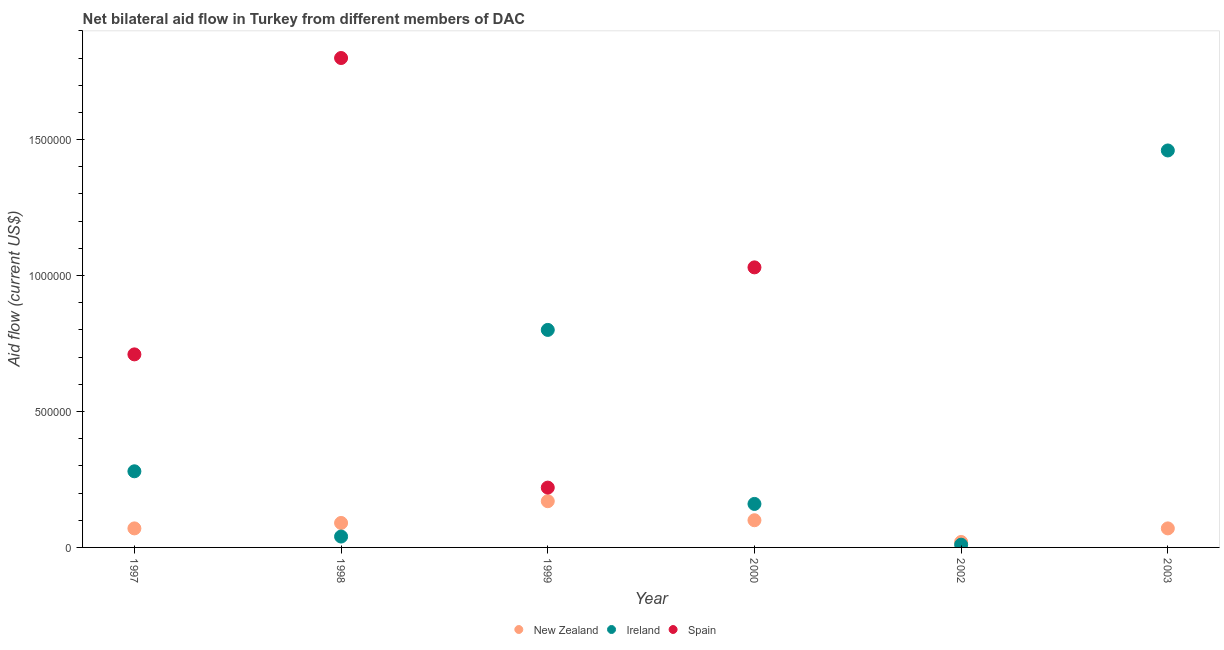How many different coloured dotlines are there?
Offer a terse response. 3. Across all years, what is the maximum amount of aid provided by ireland?
Your answer should be very brief. 1.46e+06. Across all years, what is the minimum amount of aid provided by ireland?
Give a very brief answer. 10000. In which year was the amount of aid provided by new zealand maximum?
Provide a succinct answer. 1999. What is the total amount of aid provided by spain in the graph?
Your answer should be very brief. 3.76e+06. What is the difference between the amount of aid provided by spain in 1997 and that in 1998?
Your answer should be very brief. -1.09e+06. What is the difference between the amount of aid provided by spain in 1998 and the amount of aid provided by new zealand in 2000?
Your response must be concise. 1.70e+06. What is the average amount of aid provided by new zealand per year?
Offer a very short reply. 8.67e+04. In the year 1999, what is the difference between the amount of aid provided by ireland and amount of aid provided by spain?
Keep it short and to the point. 5.80e+05. What is the ratio of the amount of aid provided by spain in 1998 to that in 2000?
Provide a succinct answer. 1.75. Is the amount of aid provided by ireland in 1999 less than that in 2003?
Your answer should be compact. Yes. Is the difference between the amount of aid provided by new zealand in 1998 and 1999 greater than the difference between the amount of aid provided by ireland in 1998 and 1999?
Provide a short and direct response. Yes. What is the difference between the highest and the second highest amount of aid provided by new zealand?
Your answer should be compact. 7.00e+04. What is the difference between the highest and the lowest amount of aid provided by spain?
Keep it short and to the point. 1.80e+06. In how many years, is the amount of aid provided by ireland greater than the average amount of aid provided by ireland taken over all years?
Your answer should be very brief. 2. Is the sum of the amount of aid provided by ireland in 2000 and 2003 greater than the maximum amount of aid provided by new zealand across all years?
Your answer should be compact. Yes. Does the amount of aid provided by spain monotonically increase over the years?
Offer a terse response. No. Is the amount of aid provided by spain strictly greater than the amount of aid provided by new zealand over the years?
Offer a terse response. No. How many dotlines are there?
Make the answer very short. 3. How many years are there in the graph?
Offer a terse response. 6. What is the difference between two consecutive major ticks on the Y-axis?
Provide a succinct answer. 5.00e+05. Are the values on the major ticks of Y-axis written in scientific E-notation?
Ensure brevity in your answer.  No. Does the graph contain grids?
Provide a short and direct response. No. How many legend labels are there?
Provide a succinct answer. 3. What is the title of the graph?
Offer a very short reply. Net bilateral aid flow in Turkey from different members of DAC. What is the label or title of the Y-axis?
Provide a succinct answer. Aid flow (current US$). What is the Aid flow (current US$) of Ireland in 1997?
Your answer should be compact. 2.80e+05. What is the Aid flow (current US$) of Spain in 1997?
Ensure brevity in your answer.  7.10e+05. What is the Aid flow (current US$) of Spain in 1998?
Provide a succinct answer. 1.80e+06. What is the Aid flow (current US$) of Spain in 1999?
Keep it short and to the point. 2.20e+05. What is the Aid flow (current US$) in Ireland in 2000?
Make the answer very short. 1.60e+05. What is the Aid flow (current US$) in Spain in 2000?
Provide a short and direct response. 1.03e+06. What is the Aid flow (current US$) in New Zealand in 2002?
Provide a short and direct response. 2.00e+04. What is the Aid flow (current US$) of Spain in 2002?
Give a very brief answer. 0. What is the Aid flow (current US$) of New Zealand in 2003?
Offer a very short reply. 7.00e+04. What is the Aid flow (current US$) of Ireland in 2003?
Ensure brevity in your answer.  1.46e+06. Across all years, what is the maximum Aid flow (current US$) in New Zealand?
Keep it short and to the point. 1.70e+05. Across all years, what is the maximum Aid flow (current US$) of Ireland?
Your response must be concise. 1.46e+06. Across all years, what is the maximum Aid flow (current US$) in Spain?
Give a very brief answer. 1.80e+06. Across all years, what is the minimum Aid flow (current US$) in New Zealand?
Keep it short and to the point. 2.00e+04. Across all years, what is the minimum Aid flow (current US$) in Ireland?
Keep it short and to the point. 10000. Across all years, what is the minimum Aid flow (current US$) of Spain?
Ensure brevity in your answer.  0. What is the total Aid flow (current US$) of New Zealand in the graph?
Provide a short and direct response. 5.20e+05. What is the total Aid flow (current US$) in Ireland in the graph?
Your answer should be compact. 2.75e+06. What is the total Aid flow (current US$) of Spain in the graph?
Give a very brief answer. 3.76e+06. What is the difference between the Aid flow (current US$) of Ireland in 1997 and that in 1998?
Your answer should be compact. 2.40e+05. What is the difference between the Aid flow (current US$) in Spain in 1997 and that in 1998?
Your answer should be compact. -1.09e+06. What is the difference between the Aid flow (current US$) in Ireland in 1997 and that in 1999?
Provide a short and direct response. -5.20e+05. What is the difference between the Aid flow (current US$) in Spain in 1997 and that in 1999?
Your response must be concise. 4.90e+05. What is the difference between the Aid flow (current US$) in New Zealand in 1997 and that in 2000?
Offer a terse response. -3.00e+04. What is the difference between the Aid flow (current US$) of Ireland in 1997 and that in 2000?
Give a very brief answer. 1.20e+05. What is the difference between the Aid flow (current US$) in Spain in 1997 and that in 2000?
Offer a very short reply. -3.20e+05. What is the difference between the Aid flow (current US$) in New Zealand in 1997 and that in 2003?
Your answer should be compact. 0. What is the difference between the Aid flow (current US$) of Ireland in 1997 and that in 2003?
Give a very brief answer. -1.18e+06. What is the difference between the Aid flow (current US$) of Ireland in 1998 and that in 1999?
Make the answer very short. -7.60e+05. What is the difference between the Aid flow (current US$) of Spain in 1998 and that in 1999?
Your answer should be compact. 1.58e+06. What is the difference between the Aid flow (current US$) in New Zealand in 1998 and that in 2000?
Give a very brief answer. -10000. What is the difference between the Aid flow (current US$) of Spain in 1998 and that in 2000?
Your response must be concise. 7.70e+05. What is the difference between the Aid flow (current US$) of New Zealand in 1998 and that in 2002?
Offer a very short reply. 7.00e+04. What is the difference between the Aid flow (current US$) in Ireland in 1998 and that in 2002?
Offer a very short reply. 3.00e+04. What is the difference between the Aid flow (current US$) of New Zealand in 1998 and that in 2003?
Offer a terse response. 2.00e+04. What is the difference between the Aid flow (current US$) in Ireland in 1998 and that in 2003?
Give a very brief answer. -1.42e+06. What is the difference between the Aid flow (current US$) in Ireland in 1999 and that in 2000?
Give a very brief answer. 6.40e+05. What is the difference between the Aid flow (current US$) of Spain in 1999 and that in 2000?
Offer a terse response. -8.10e+05. What is the difference between the Aid flow (current US$) of New Zealand in 1999 and that in 2002?
Offer a very short reply. 1.50e+05. What is the difference between the Aid flow (current US$) of Ireland in 1999 and that in 2002?
Ensure brevity in your answer.  7.90e+05. What is the difference between the Aid flow (current US$) of New Zealand in 1999 and that in 2003?
Offer a terse response. 1.00e+05. What is the difference between the Aid flow (current US$) in Ireland in 1999 and that in 2003?
Ensure brevity in your answer.  -6.60e+05. What is the difference between the Aid flow (current US$) of New Zealand in 2000 and that in 2002?
Ensure brevity in your answer.  8.00e+04. What is the difference between the Aid flow (current US$) in Ireland in 2000 and that in 2003?
Offer a very short reply. -1.30e+06. What is the difference between the Aid flow (current US$) of New Zealand in 2002 and that in 2003?
Ensure brevity in your answer.  -5.00e+04. What is the difference between the Aid flow (current US$) of Ireland in 2002 and that in 2003?
Offer a very short reply. -1.45e+06. What is the difference between the Aid flow (current US$) in New Zealand in 1997 and the Aid flow (current US$) in Ireland in 1998?
Offer a very short reply. 3.00e+04. What is the difference between the Aid flow (current US$) in New Zealand in 1997 and the Aid flow (current US$) in Spain in 1998?
Provide a succinct answer. -1.73e+06. What is the difference between the Aid flow (current US$) of Ireland in 1997 and the Aid flow (current US$) of Spain in 1998?
Offer a very short reply. -1.52e+06. What is the difference between the Aid flow (current US$) in New Zealand in 1997 and the Aid flow (current US$) in Ireland in 1999?
Keep it short and to the point. -7.30e+05. What is the difference between the Aid flow (current US$) in New Zealand in 1997 and the Aid flow (current US$) in Spain in 1999?
Your answer should be compact. -1.50e+05. What is the difference between the Aid flow (current US$) in New Zealand in 1997 and the Aid flow (current US$) in Spain in 2000?
Make the answer very short. -9.60e+05. What is the difference between the Aid flow (current US$) of Ireland in 1997 and the Aid flow (current US$) of Spain in 2000?
Keep it short and to the point. -7.50e+05. What is the difference between the Aid flow (current US$) in New Zealand in 1997 and the Aid flow (current US$) in Ireland in 2002?
Make the answer very short. 6.00e+04. What is the difference between the Aid flow (current US$) in New Zealand in 1997 and the Aid flow (current US$) in Ireland in 2003?
Your response must be concise. -1.39e+06. What is the difference between the Aid flow (current US$) in New Zealand in 1998 and the Aid flow (current US$) in Ireland in 1999?
Your answer should be very brief. -7.10e+05. What is the difference between the Aid flow (current US$) of New Zealand in 1998 and the Aid flow (current US$) of Spain in 1999?
Provide a short and direct response. -1.30e+05. What is the difference between the Aid flow (current US$) in Ireland in 1998 and the Aid flow (current US$) in Spain in 1999?
Your answer should be compact. -1.80e+05. What is the difference between the Aid flow (current US$) of New Zealand in 1998 and the Aid flow (current US$) of Ireland in 2000?
Your answer should be very brief. -7.00e+04. What is the difference between the Aid flow (current US$) in New Zealand in 1998 and the Aid flow (current US$) in Spain in 2000?
Ensure brevity in your answer.  -9.40e+05. What is the difference between the Aid flow (current US$) in Ireland in 1998 and the Aid flow (current US$) in Spain in 2000?
Your answer should be very brief. -9.90e+05. What is the difference between the Aid flow (current US$) of New Zealand in 1998 and the Aid flow (current US$) of Ireland in 2003?
Make the answer very short. -1.37e+06. What is the difference between the Aid flow (current US$) of New Zealand in 1999 and the Aid flow (current US$) of Spain in 2000?
Your response must be concise. -8.60e+05. What is the difference between the Aid flow (current US$) of Ireland in 1999 and the Aid flow (current US$) of Spain in 2000?
Make the answer very short. -2.30e+05. What is the difference between the Aid flow (current US$) of New Zealand in 1999 and the Aid flow (current US$) of Ireland in 2002?
Offer a terse response. 1.60e+05. What is the difference between the Aid flow (current US$) of New Zealand in 1999 and the Aid flow (current US$) of Ireland in 2003?
Give a very brief answer. -1.29e+06. What is the difference between the Aid flow (current US$) of New Zealand in 2000 and the Aid flow (current US$) of Ireland in 2002?
Provide a short and direct response. 9.00e+04. What is the difference between the Aid flow (current US$) of New Zealand in 2000 and the Aid flow (current US$) of Ireland in 2003?
Offer a very short reply. -1.36e+06. What is the difference between the Aid flow (current US$) of New Zealand in 2002 and the Aid flow (current US$) of Ireland in 2003?
Your response must be concise. -1.44e+06. What is the average Aid flow (current US$) of New Zealand per year?
Offer a terse response. 8.67e+04. What is the average Aid flow (current US$) of Ireland per year?
Offer a very short reply. 4.58e+05. What is the average Aid flow (current US$) in Spain per year?
Provide a short and direct response. 6.27e+05. In the year 1997, what is the difference between the Aid flow (current US$) in New Zealand and Aid flow (current US$) in Ireland?
Give a very brief answer. -2.10e+05. In the year 1997, what is the difference between the Aid flow (current US$) of New Zealand and Aid flow (current US$) of Spain?
Ensure brevity in your answer.  -6.40e+05. In the year 1997, what is the difference between the Aid flow (current US$) in Ireland and Aid flow (current US$) in Spain?
Offer a very short reply. -4.30e+05. In the year 1998, what is the difference between the Aid flow (current US$) of New Zealand and Aid flow (current US$) of Ireland?
Your response must be concise. 5.00e+04. In the year 1998, what is the difference between the Aid flow (current US$) of New Zealand and Aid flow (current US$) of Spain?
Give a very brief answer. -1.71e+06. In the year 1998, what is the difference between the Aid flow (current US$) in Ireland and Aid flow (current US$) in Spain?
Offer a terse response. -1.76e+06. In the year 1999, what is the difference between the Aid flow (current US$) of New Zealand and Aid flow (current US$) of Ireland?
Provide a short and direct response. -6.30e+05. In the year 1999, what is the difference between the Aid flow (current US$) of Ireland and Aid flow (current US$) of Spain?
Offer a terse response. 5.80e+05. In the year 2000, what is the difference between the Aid flow (current US$) of New Zealand and Aid flow (current US$) of Spain?
Your response must be concise. -9.30e+05. In the year 2000, what is the difference between the Aid flow (current US$) of Ireland and Aid flow (current US$) of Spain?
Provide a short and direct response. -8.70e+05. In the year 2003, what is the difference between the Aid flow (current US$) in New Zealand and Aid flow (current US$) in Ireland?
Make the answer very short. -1.39e+06. What is the ratio of the Aid flow (current US$) in Spain in 1997 to that in 1998?
Your response must be concise. 0.39. What is the ratio of the Aid flow (current US$) in New Zealand in 1997 to that in 1999?
Your response must be concise. 0.41. What is the ratio of the Aid flow (current US$) in Ireland in 1997 to that in 1999?
Your answer should be compact. 0.35. What is the ratio of the Aid flow (current US$) in Spain in 1997 to that in 1999?
Your answer should be very brief. 3.23. What is the ratio of the Aid flow (current US$) of Spain in 1997 to that in 2000?
Your answer should be compact. 0.69. What is the ratio of the Aid flow (current US$) in New Zealand in 1997 to that in 2003?
Make the answer very short. 1. What is the ratio of the Aid flow (current US$) of Ireland in 1997 to that in 2003?
Provide a succinct answer. 0.19. What is the ratio of the Aid flow (current US$) of New Zealand in 1998 to that in 1999?
Give a very brief answer. 0.53. What is the ratio of the Aid flow (current US$) of Spain in 1998 to that in 1999?
Make the answer very short. 8.18. What is the ratio of the Aid flow (current US$) in Ireland in 1998 to that in 2000?
Give a very brief answer. 0.25. What is the ratio of the Aid flow (current US$) in Spain in 1998 to that in 2000?
Ensure brevity in your answer.  1.75. What is the ratio of the Aid flow (current US$) in Ireland in 1998 to that in 2003?
Your answer should be very brief. 0.03. What is the ratio of the Aid flow (current US$) in New Zealand in 1999 to that in 2000?
Your response must be concise. 1.7. What is the ratio of the Aid flow (current US$) of Spain in 1999 to that in 2000?
Ensure brevity in your answer.  0.21. What is the ratio of the Aid flow (current US$) in New Zealand in 1999 to that in 2002?
Your response must be concise. 8.5. What is the ratio of the Aid flow (current US$) of New Zealand in 1999 to that in 2003?
Provide a succinct answer. 2.43. What is the ratio of the Aid flow (current US$) of Ireland in 1999 to that in 2003?
Your response must be concise. 0.55. What is the ratio of the Aid flow (current US$) in New Zealand in 2000 to that in 2003?
Ensure brevity in your answer.  1.43. What is the ratio of the Aid flow (current US$) of Ireland in 2000 to that in 2003?
Make the answer very short. 0.11. What is the ratio of the Aid flow (current US$) in New Zealand in 2002 to that in 2003?
Offer a very short reply. 0.29. What is the ratio of the Aid flow (current US$) of Ireland in 2002 to that in 2003?
Give a very brief answer. 0.01. What is the difference between the highest and the second highest Aid flow (current US$) of New Zealand?
Make the answer very short. 7.00e+04. What is the difference between the highest and the second highest Aid flow (current US$) in Spain?
Your answer should be very brief. 7.70e+05. What is the difference between the highest and the lowest Aid flow (current US$) of Ireland?
Your response must be concise. 1.45e+06. What is the difference between the highest and the lowest Aid flow (current US$) in Spain?
Give a very brief answer. 1.80e+06. 